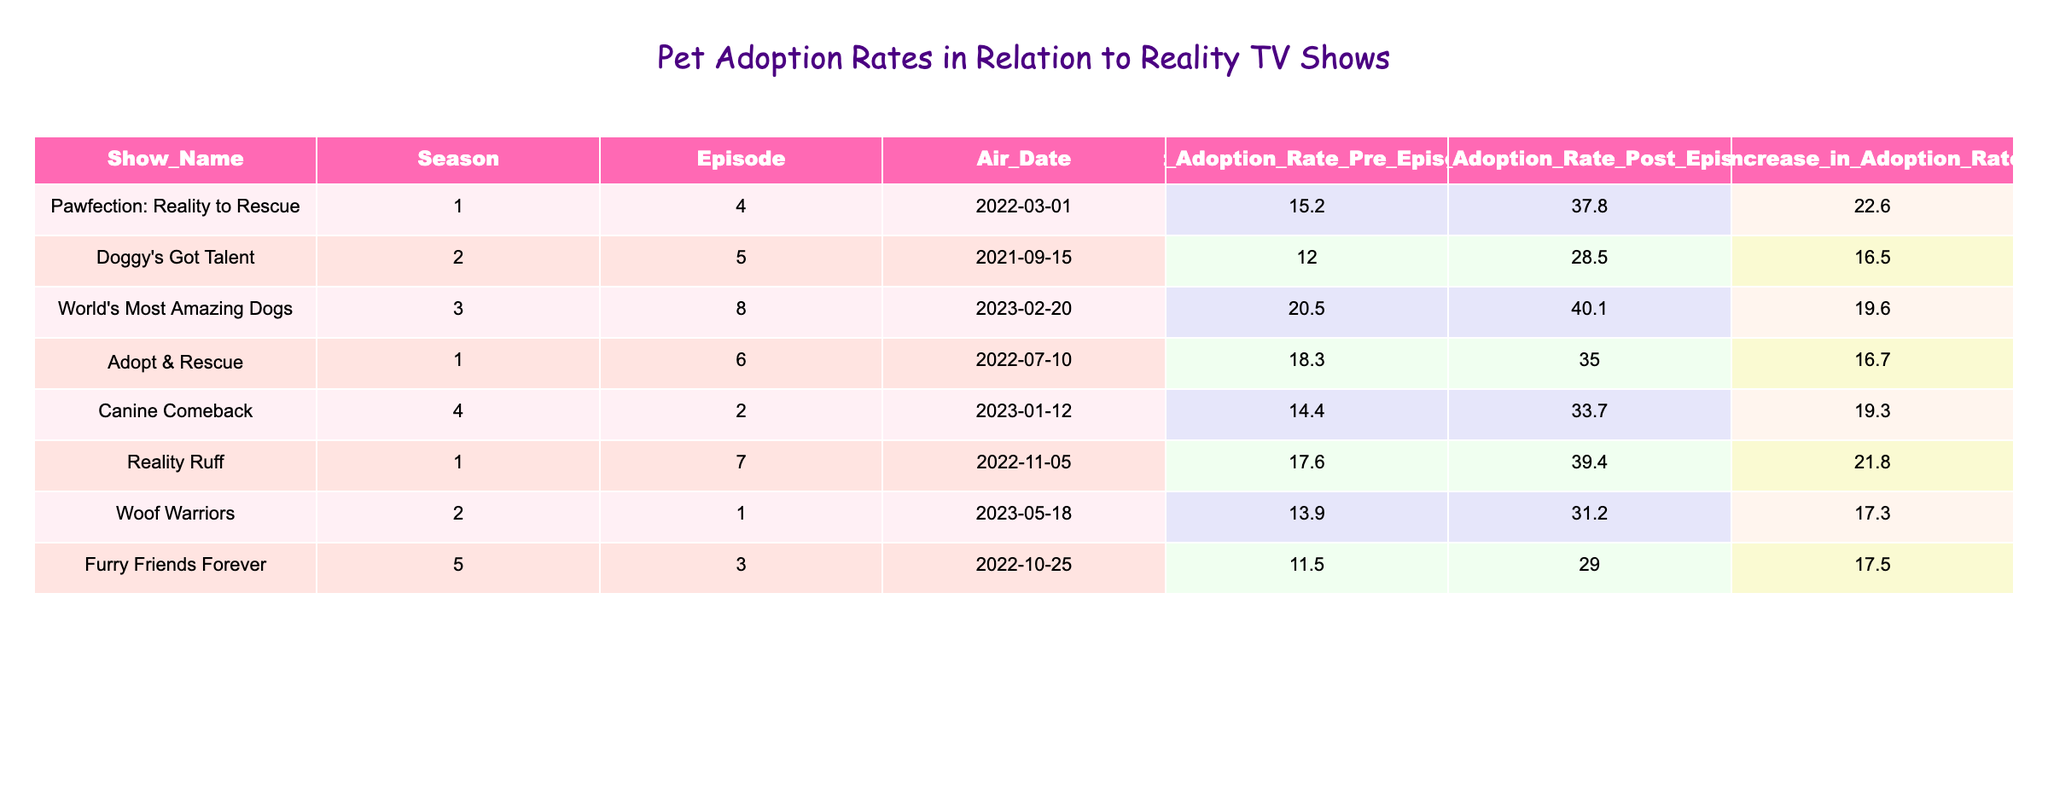What was the pet adoption rate before the episode of "Pawfection: Reality to Rescue"? The table indicates that the pet adoption rate before the episode aired was 15.2.
Answer: 15.2 Which show had the highest increase in the pet adoption rate? By checking the "Increase in Adoption Rate" column, "Pawfection: Reality to Rescue" shows the highest increase at 22.6.
Answer: Pawfection: Reality to Rescue What is the average pet adoption rate after the episodes aired for all the shows? First, sum the post-episode rates: 37.8 + 28.5 + 40.1 + 35.0 + 33.7 + 39.4 + 31.2 + 29.0 = 304.7. Then, divide this by the number of shows (8): 304.7 / 8 = 38.09.
Answer: 38.09 Did "Doggy's Got Talent" increase the pet adoption rate by more than 20%? The increase in adoption rate for "Doggy's Got Talent" is 16.5, which is less than 20%, thus the answer is no.
Answer: No What is the difference between the average pet adoption rate before and after the episodes aired? The average before episodes is calculated as (15.2 + 12.0 + 20.5 + 18.3 + 14.4 + 17.6 + 13.9 + 11.5) / 8 = 16.1. The average after is (37.8 + 28.5 + 40.1 + 35.0 + 33.7 + 39.4 + 31.2 + 29.0) / 8 = 35.4. The difference is 35.4 - 16.1 = 19.3.
Answer: 19.3 Which shows had a post-episode pet adoption rate below 30%? Referring to the "Pet Adoption Rate Post Episode" column, "Doggy's Got Talent" (28.5) and "Furry Friends Forever" (29.0) both had rates below 30%.
Answer: Doggy's Got Talent, Furry Friends Forever What is the total increase in pet adoption rates across all shows? The total increase can be calculated by summing all the values in the "Increase in Adoption Rate" column: 22.6 + 16.5 + 19.6 + 16.7 + 19.3 + 21.8 + 17.3 + 17.5 = 134.3.
Answer: 134.3 Which show has a pet adoption rate after its episode of 35% or greater? By reviewing the post-episode rates, the shows with rates of 35% or greater are "Pawfection: Reality to Rescue" (37.8), "World's Most Amazing Dogs" (40.1), "Adopt & Rescue" (35.0), "Reality Ruff" (39.4), and "Canine Comeback" (33.7).
Answer: Pawfection: Reality to Rescue, World's Most Amazing Dogs, Adopt & Rescue, Reality Ruff, Canine Comeback 